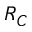Convert formula to latex. <formula><loc_0><loc_0><loc_500><loc_500>R _ { C }</formula> 